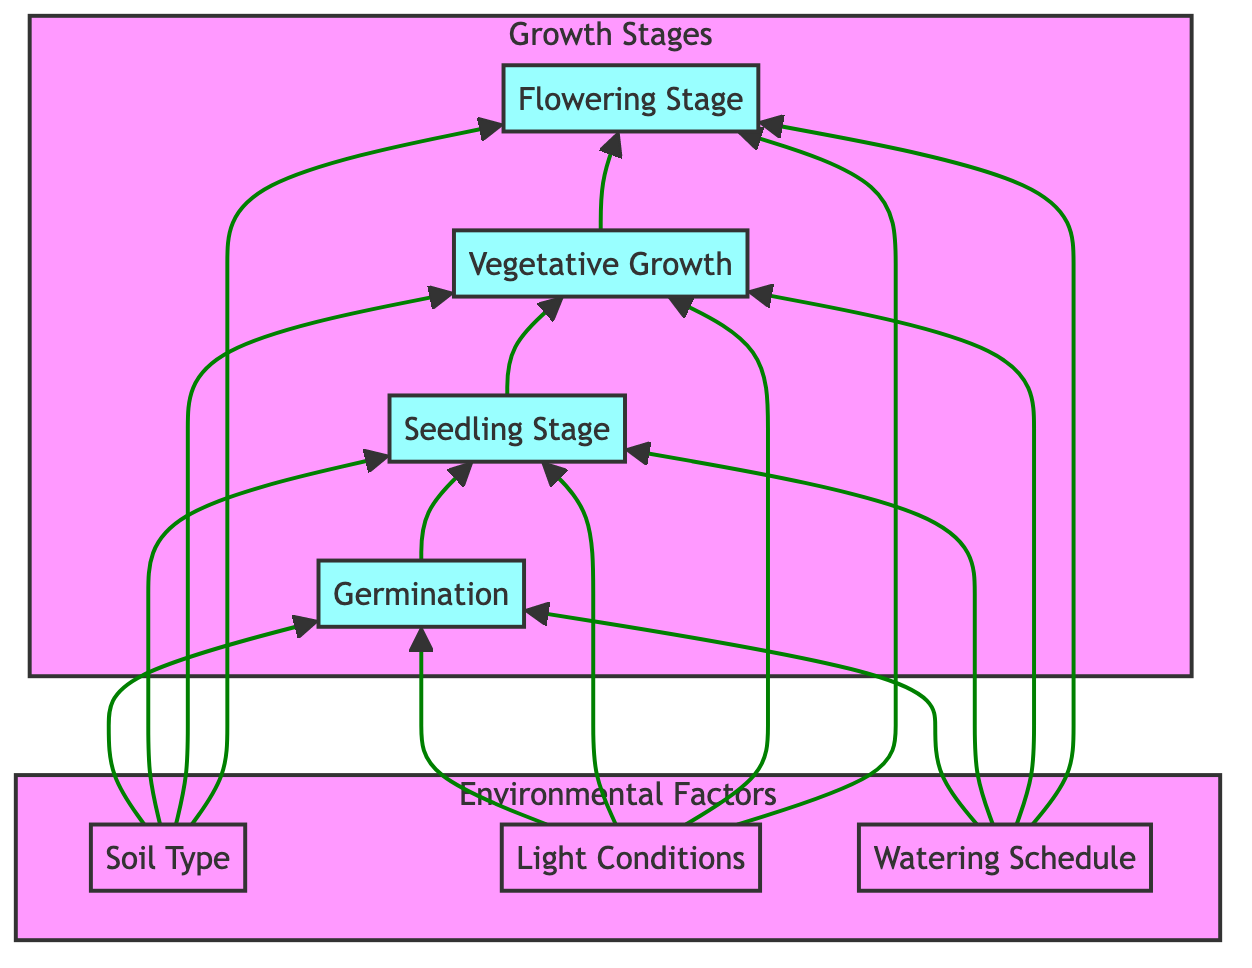What is the first stage of plant growth shown in the diagram? The diagram starts with the first stage defined, which is "Germination." It is positioned at the bottom of the growth stages section, indicating that it is the initial stage.
Answer: Germination How many growth stages are represented in the diagram? Upon examining the growth stages section, it lists four distinct stages: Germination, Seedling Stage, Vegetative Growth, and Flowering Stage. Therefore, the total count is four.
Answer: Four What environmental factor influences all four plant growth stages? By analyzing the diagram, it's clear that "Soil Type," "Light Conditions," and "Watering Schedule" all connect to every growth stage, indicating they affect Germination, Seedling Stage, Vegetative Growth, and Flowering Stage. Therefore, they all influence each stage, including the number of connections present.
Answer: Soil Type Which stage of plant growth immediately follows the Seedling Stage? The diagram depicts the progression from the Seedling Stage upward to the next stage, which is "Vegetative Growth." This direct connection shows the flow of development.
Answer: Vegetative Growth How does light condition relate to plant growth stages in the diagram? The diagram shows that "Light Conditions" connect to all growth stages, indicating that they play a role in each stage of development from Germination to Flowering. It suggests that all growth stages are influenced by light availability.
Answer: Connects to all stages What is the relationship between the Flowering Stage and environmental factors? Analyzing the connections, the Flowering Stage receives inputs from all three environmental factors: Soil Type, Light Conditions, and Watering Schedule. This indicates that the Flowering Stage is significantly influenced by these factors, shaping its development and eventual success.
Answer: Influenced by all factors Which environmental factor might the plant require daily attention during its growth stages? The "Watering Schedule" connects to every growth stage, suggesting regular watering is essential, especially as factors vary according to the plant's needs and the growing conditions. This insight into watering frequency indicates that plants often necessitate daily or frequent care.
Answer: Watering Schedule What is depicted at the top of the diagram? The diagram classes the growth stages in a top section distinctly from the environmental factors below. This arrangement underscores that plant growth starts from the bottom and ascends through each stage, leading to flowering visually represented at the top.
Answer: Growth Stages 